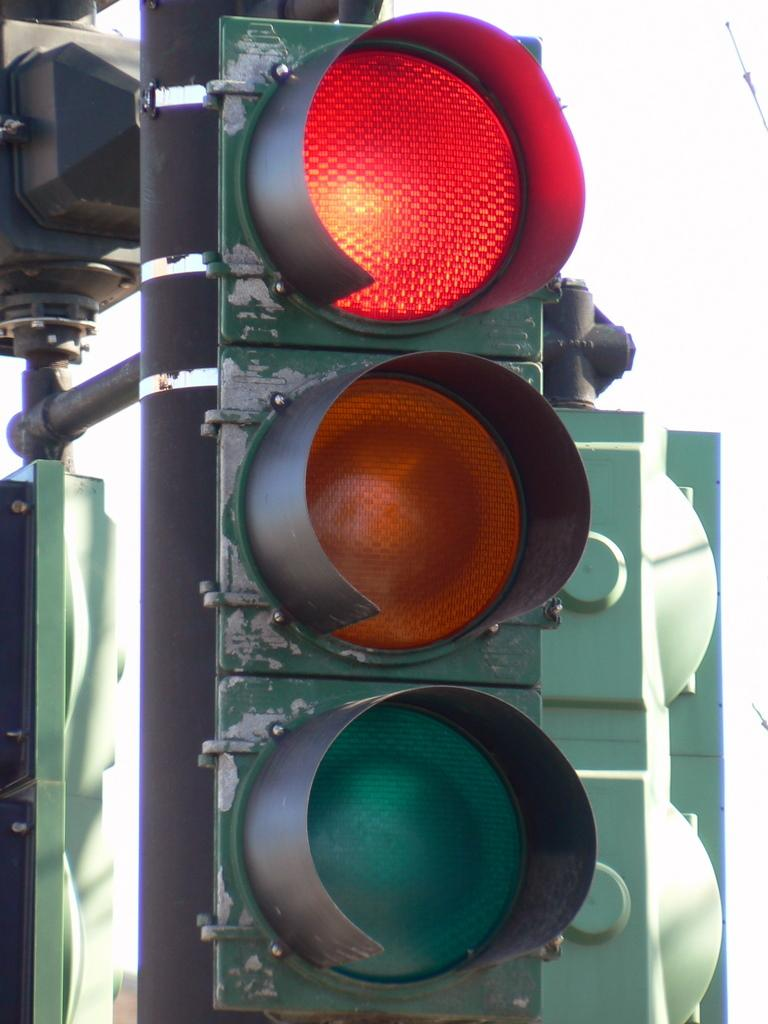What type of objects can be seen in the image that regulate traffic? There are traffic signals in the image. What part of the natural environment is visible in the image? The sky is visible in the image. What type of servant can be seen in the image? There is no servant present in the image. Is there a swing visible in the image? There is no swing present in the image. 